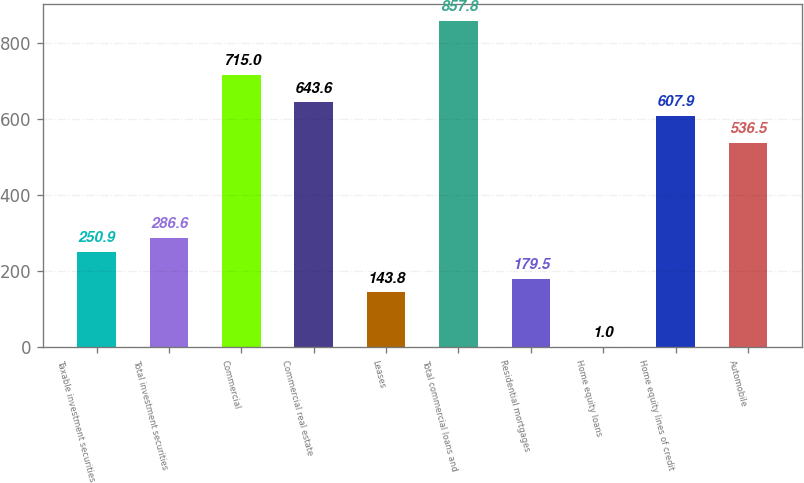<chart> <loc_0><loc_0><loc_500><loc_500><bar_chart><fcel>Taxable investment securities<fcel>Total investment securities<fcel>Commercial<fcel>Commercial real estate<fcel>Leases<fcel>Total commercial loans and<fcel>Residential mortgages<fcel>Home equity loans<fcel>Home equity lines of credit<fcel>Automobile<nl><fcel>250.9<fcel>286.6<fcel>715<fcel>643.6<fcel>143.8<fcel>857.8<fcel>179.5<fcel>1<fcel>607.9<fcel>536.5<nl></chart> 